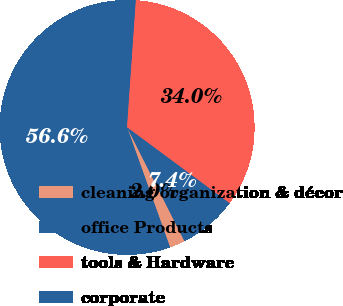Convert chart to OTSL. <chart><loc_0><loc_0><loc_500><loc_500><pie_chart><fcel>cleaning organization & décor<fcel>office Products<fcel>tools & Hardware<fcel>corporate<nl><fcel>1.96%<fcel>56.58%<fcel>34.04%<fcel>7.42%<nl></chart> 